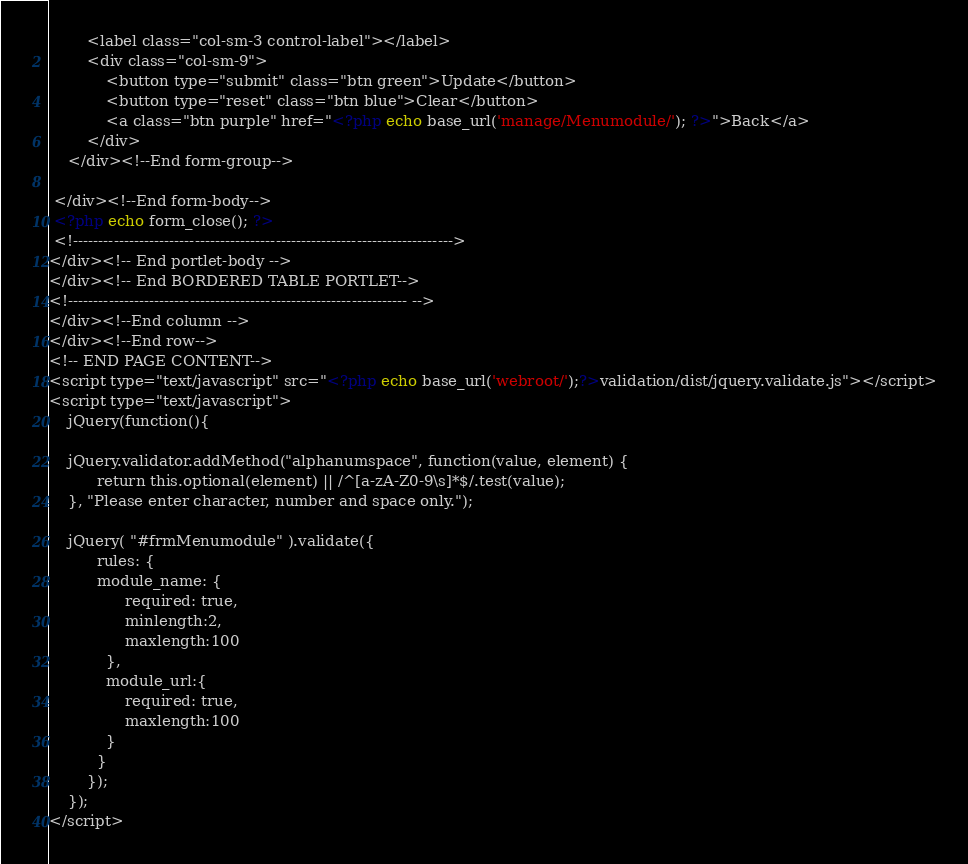<code> <loc_0><loc_0><loc_500><loc_500><_PHP_>		<label class="col-sm-3 control-label"></label>
		<div class="col-sm-9">
			<button type="submit" class="btn green">Update</button>
			<button type="reset" class="btn blue">Clear</button>
			<a class="btn purple" href="<?php echo base_url('manage/Menumodule/'); ?>">Back</a>
		</div>
	</div><!--End form-group-->
	
 </div><!--End form-body-->
 <?php echo form_close(); ?>
 <!--------------------------------------------------------------------------->
</div><!-- End portlet-body -->
</div><!-- End BORDERED TABLE PORTLET-->
<!------------------------------------------------------------------- -->
</div><!--End column -->
</div><!--End row-->
<!-- END PAGE CONTENT-->
<script type="text/javascript" src="<?php echo base_url('webroot/');?>validation/dist/jquery.validate.js"></script>
<script type="text/javascript">
	jQuery(function(){
		
	jQuery.validator.addMethod("alphanumspace", function(value, element) {
		  return this.optional(element) || /^[a-zA-Z0-9\s]*$/.test(value);
	}, "Please enter character, number and space only.");
	
	jQuery( "#frmMenumodule" ).validate({
		  rules: {
		  module_name: {
		        required: true,
		        minlength:2,
		        maxlength:100
		    },
			module_url:{
				required: true,
				maxlength:100
			}
		  }
		});	
	});
</script></code> 